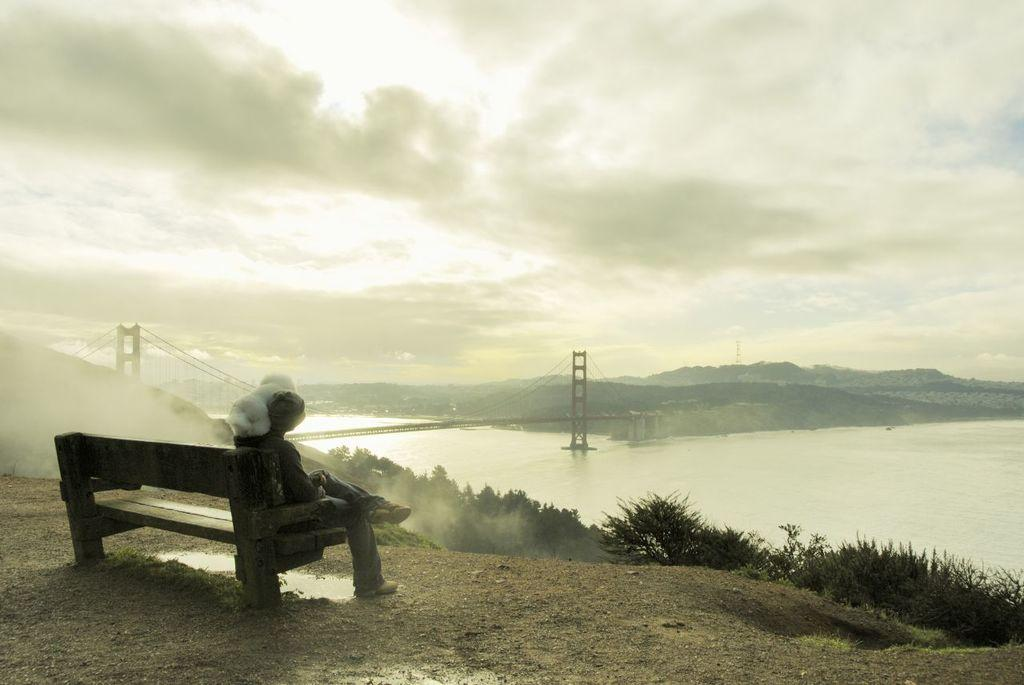What is the person in the image doing? The person is sitting on a bench in the image. What is near the person in the image? The person is near plants in the image. What can be seen in the background of the image? There is a bridge, a beach, mountains, and the sky visible in the background of the image. How is the sky in the image? The sky is covered with clouds in the image. What type of fruit is the person holding in the image? There is no fruit present in the image; the person is sitting on a bench near plants. How many stitches are visible on the person's clothing in the image? There is no information about the person's clothing or stitches in the image. 